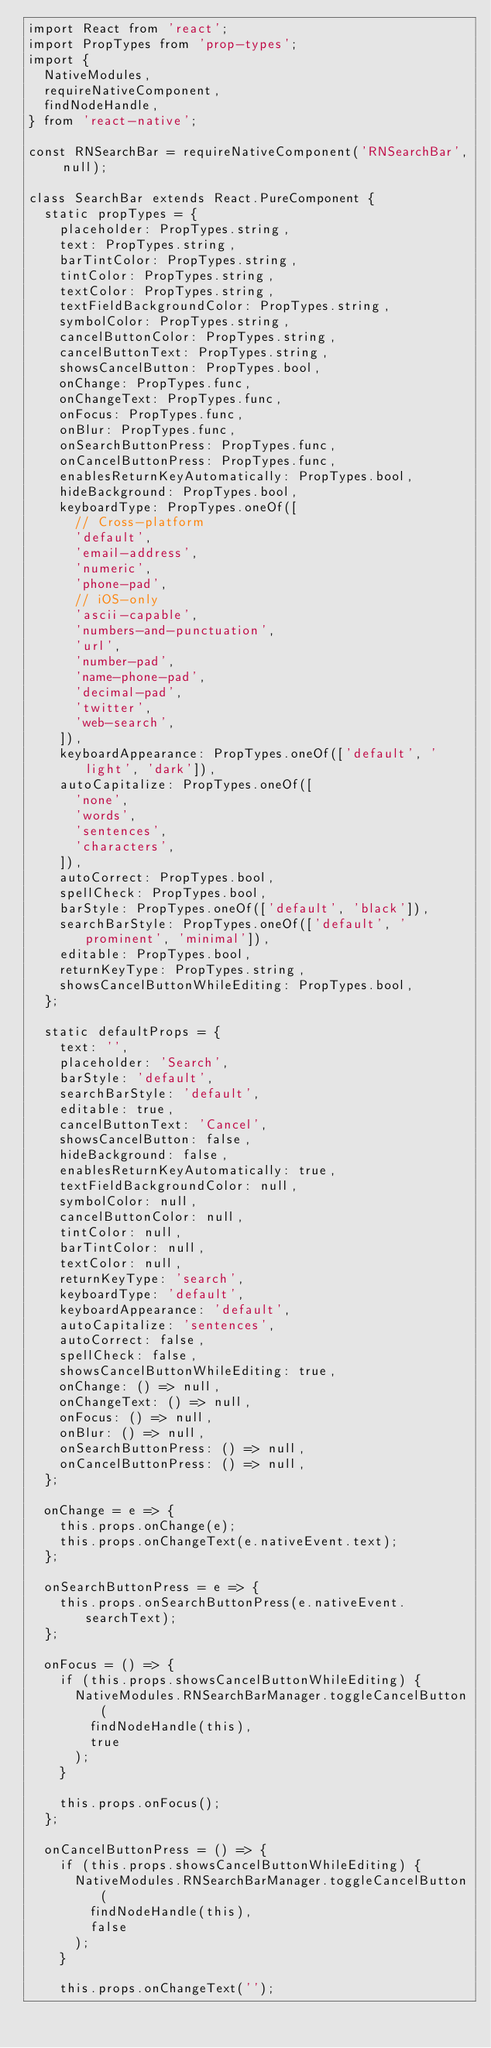Convert code to text. <code><loc_0><loc_0><loc_500><loc_500><_JavaScript_>import React from 'react';
import PropTypes from 'prop-types';
import {
  NativeModules,
  requireNativeComponent,
  findNodeHandle,
} from 'react-native';

const RNSearchBar = requireNativeComponent('RNSearchBar', null);

class SearchBar extends React.PureComponent {
  static propTypes = {
    placeholder: PropTypes.string,
    text: PropTypes.string,
    barTintColor: PropTypes.string,
    tintColor: PropTypes.string,
    textColor: PropTypes.string,
    textFieldBackgroundColor: PropTypes.string,
    symbolColor: PropTypes.string,
    cancelButtonColor: PropTypes.string,
    cancelButtonText: PropTypes.string,
    showsCancelButton: PropTypes.bool,
    onChange: PropTypes.func,
    onChangeText: PropTypes.func,
    onFocus: PropTypes.func,
    onBlur: PropTypes.func,
    onSearchButtonPress: PropTypes.func,
    onCancelButtonPress: PropTypes.func,
    enablesReturnKeyAutomatically: PropTypes.bool,
    hideBackground: PropTypes.bool,
    keyboardType: PropTypes.oneOf([
      // Cross-platform
      'default',
      'email-address',
      'numeric',
      'phone-pad',
      // iOS-only
      'ascii-capable',
      'numbers-and-punctuation',
      'url',
      'number-pad',
      'name-phone-pad',
      'decimal-pad',
      'twitter',
      'web-search',
    ]),
    keyboardAppearance: PropTypes.oneOf(['default', 'light', 'dark']),
    autoCapitalize: PropTypes.oneOf([
      'none',
      'words',
      'sentences',
      'characters',
    ]),
    autoCorrect: PropTypes.bool,
    spellCheck: PropTypes.bool,
    barStyle: PropTypes.oneOf(['default', 'black']),
    searchBarStyle: PropTypes.oneOf(['default', 'prominent', 'minimal']),
    editable: PropTypes.bool,
    returnKeyType: PropTypes.string,
    showsCancelButtonWhileEditing: PropTypes.bool,
  };

  static defaultProps = {
    text: '',
    placeholder: 'Search',
    barStyle: 'default',
    searchBarStyle: 'default',
    editable: true,
    cancelButtonText: 'Cancel',
    showsCancelButton: false,
    hideBackground: false,
    enablesReturnKeyAutomatically: true,
    textFieldBackgroundColor: null,
    symbolColor: null,
    cancelButtonColor: null,
    tintColor: null,
    barTintColor: null,
    textColor: null,
    returnKeyType: 'search',
    keyboardType: 'default',
    keyboardAppearance: 'default',
    autoCapitalize: 'sentences',
    autoCorrect: false,
    spellCheck: false,
    showsCancelButtonWhileEditing: true,
    onChange: () => null,
    onChangeText: () => null,
    onFocus: () => null,
    onBlur: () => null,
    onSearchButtonPress: () => null,
    onCancelButtonPress: () => null,
  };

  onChange = e => {
    this.props.onChange(e);
    this.props.onChangeText(e.nativeEvent.text);
  };

  onSearchButtonPress = e => {
    this.props.onSearchButtonPress(e.nativeEvent.searchText);
  };

  onFocus = () => {
    if (this.props.showsCancelButtonWhileEditing) {
      NativeModules.RNSearchBarManager.toggleCancelButton(
        findNodeHandle(this),
        true
      );
    }

    this.props.onFocus();
  };

  onCancelButtonPress = () => {
    if (this.props.showsCancelButtonWhileEditing) {
      NativeModules.RNSearchBarManager.toggleCancelButton(
        findNodeHandle(this),
        false
      );
    }

    this.props.onChangeText('');</code> 